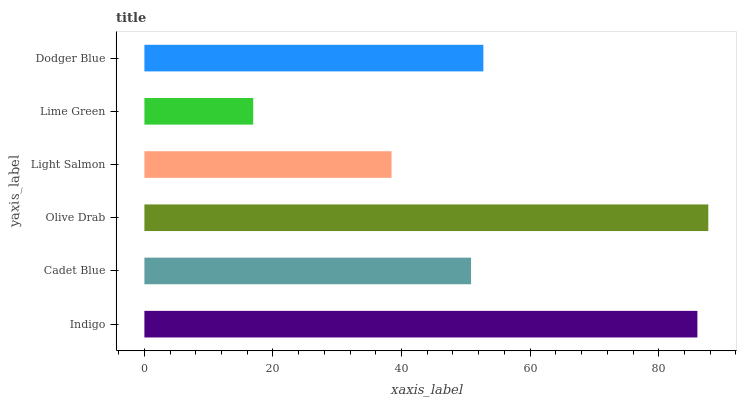Is Lime Green the minimum?
Answer yes or no. Yes. Is Olive Drab the maximum?
Answer yes or no. Yes. Is Cadet Blue the minimum?
Answer yes or no. No. Is Cadet Blue the maximum?
Answer yes or no. No. Is Indigo greater than Cadet Blue?
Answer yes or no. Yes. Is Cadet Blue less than Indigo?
Answer yes or no. Yes. Is Cadet Blue greater than Indigo?
Answer yes or no. No. Is Indigo less than Cadet Blue?
Answer yes or no. No. Is Dodger Blue the high median?
Answer yes or no. Yes. Is Cadet Blue the low median?
Answer yes or no. Yes. Is Cadet Blue the high median?
Answer yes or no. No. Is Olive Drab the low median?
Answer yes or no. No. 